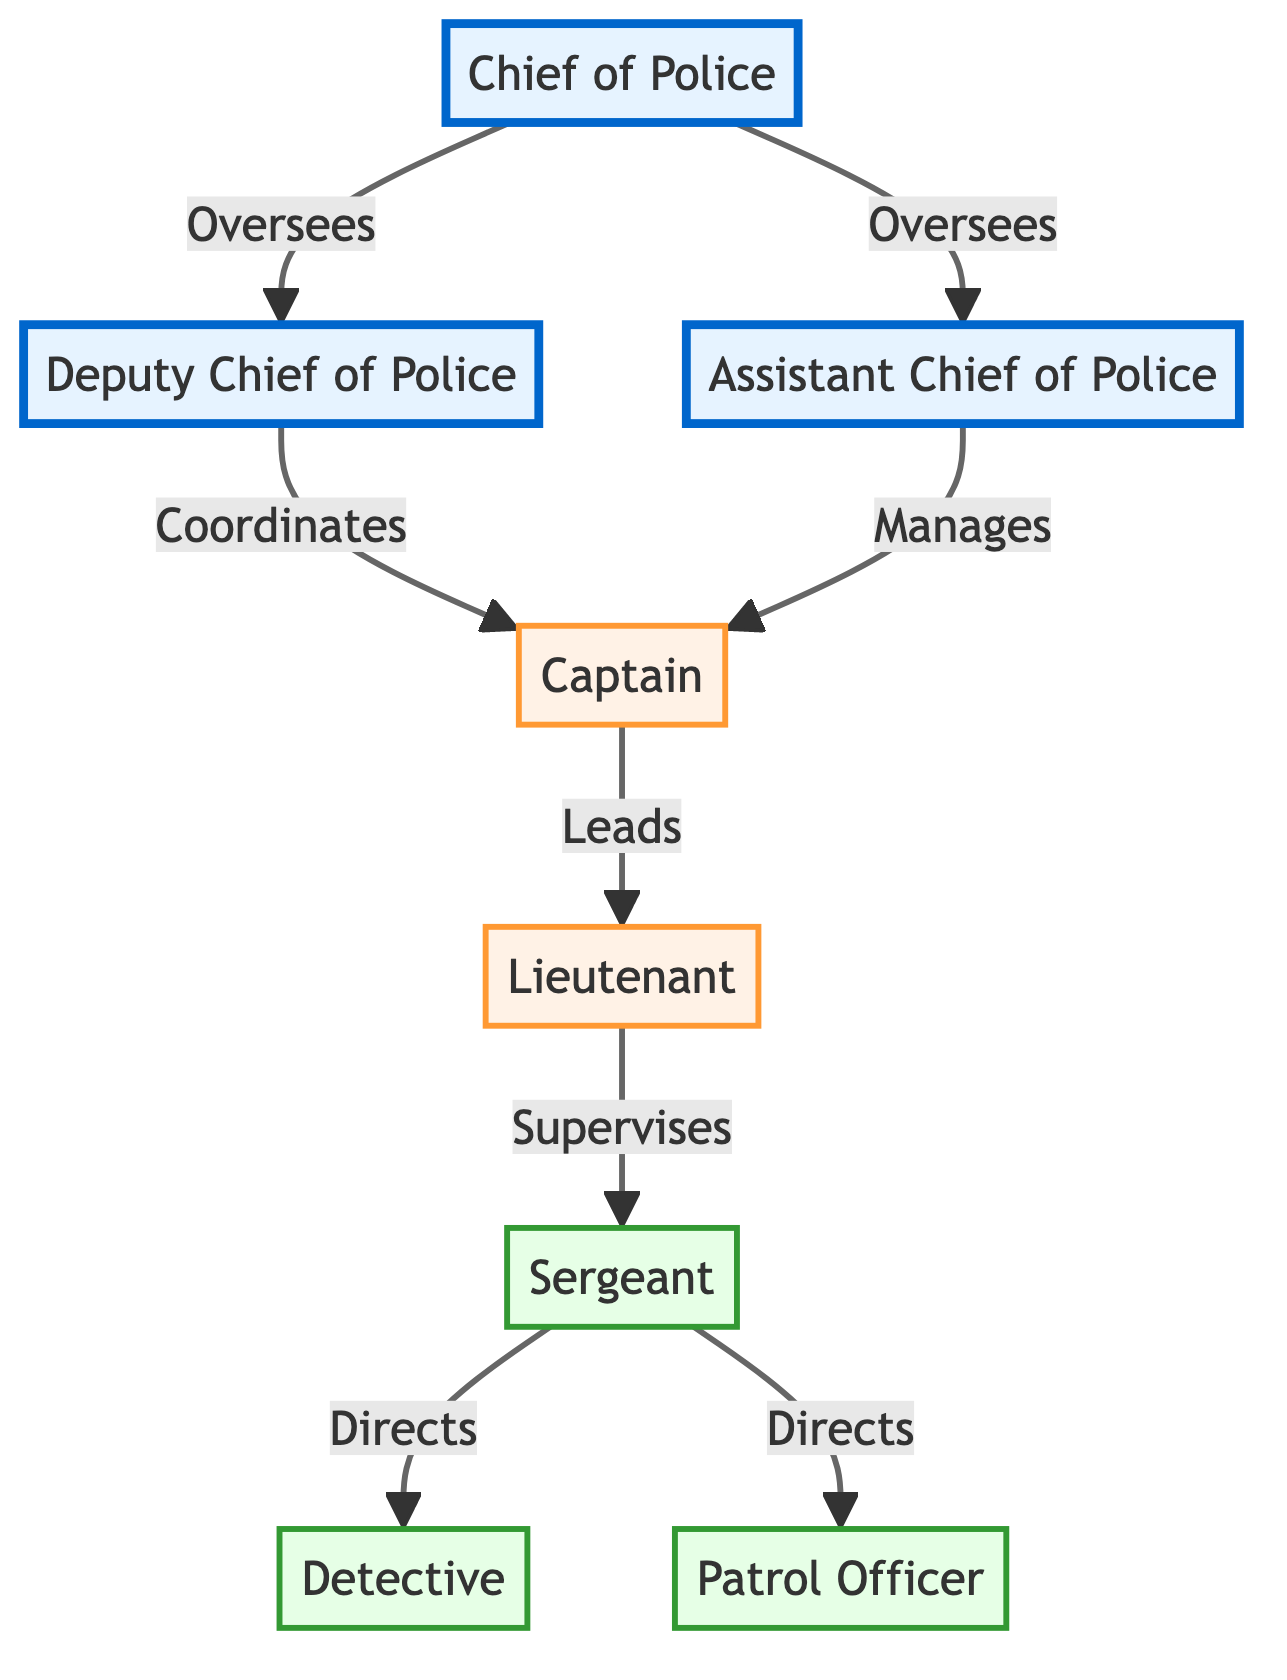What is the top position in the police department hierarchy? The diagram shows the "Chief of Police" at the top of the pyramid, indicating it is the highest rank in the organizational structure.
Answer: Chief of Police How many positions are directly overseen by the Chief of Police? In the diagram, the Chief of Police oversees two positions: the Deputy Chief of Police and the Assistant Chief of Police, which are both directly connected to the Chief.
Answer: 2 Which rank supervises the Sergeant? The diagram indicates that the Sergeant is supervised by the Lieutenant, as shown by the direct line connecting them with the label "Supervises."
Answer: Lieutenant What is the relationship between the Deputy Chief of Police and Captain? The diagram illustrates that the Deputy Chief of Police "Coordinates" with the Captain, indicating a collaborative relationship between these two ranks.
Answer: Coordinates How many operational roles are depicted in the diagram? The diagram shows three operational roles: Sergeant, Detective, and Patrol Officer, as they are all categorized under the operational class.
Answer: 3 Which officer has a higher rank: a Detective or a Patrol Officer? The organizational structure in the diagram shows a hierarchical relationship where the Detective is positioned above the Patrol Officer, indicating that the Detective has a higher rank.
Answer: Detective What type of diagram is this? The diagram is presented in an organizational chart format, which clearly displays the hierarchy and roles within the police department.
Answer: Organizational chart What color represents the executive class in the diagram? The color used for the executive class is light blue (#e6f3ff), which is specifically designated for the top-tier positions in the hierarchy.
Answer: Light blue How many total positions are depicted in the diagram? Counting all the unique roles shown, the diagram presents a total of eight distinct positions in the police department hierarchy.
Answer: 8 